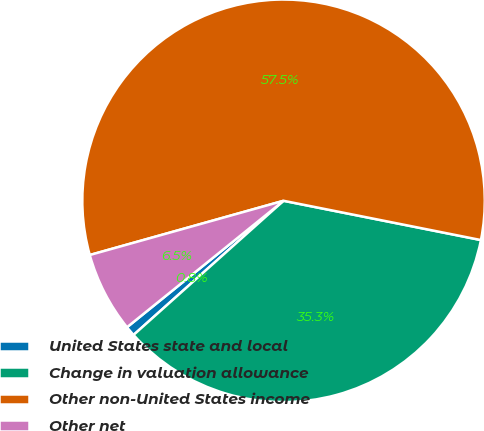Convert chart to OTSL. <chart><loc_0><loc_0><loc_500><loc_500><pie_chart><fcel>United States state and local<fcel>Change in valuation allowance<fcel>Other non-United States income<fcel>Other net<nl><fcel>0.8%<fcel>35.26%<fcel>57.47%<fcel>6.47%<nl></chart> 